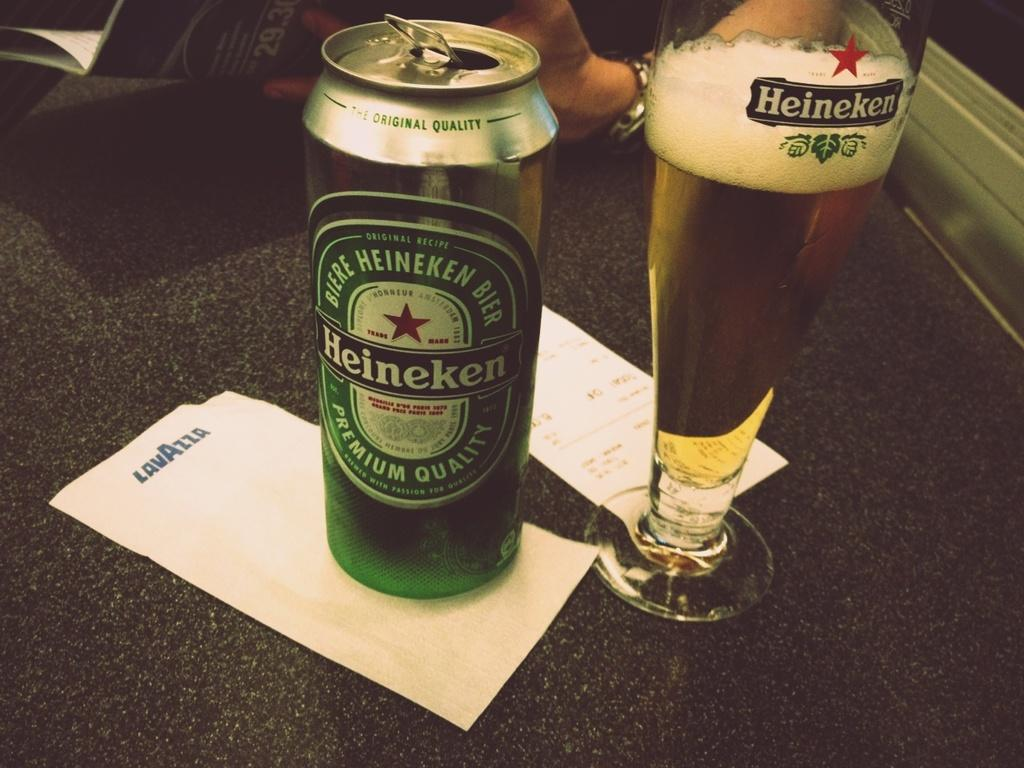<image>
Render a clear and concise summary of the photo. a can of biere heineken bier standing next to a glass labeled heineken 